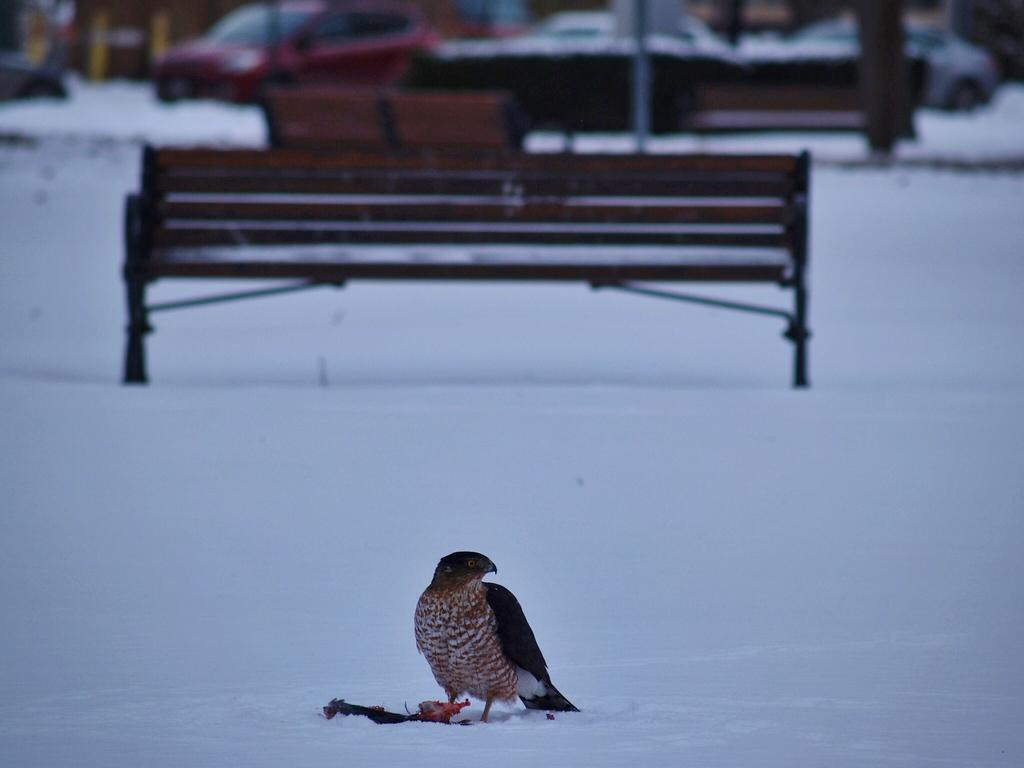What type of animal can be seen in the image? There is a bird in the image. Where is the bird located? The bird is on the snow. What structures are visible in the background of the image? There is a bench, a pole, and a car in the background of the image. What type of story is the bird telling in the image? There is no indication in the image that the bird is telling a story, as birds do not communicate through stories. 